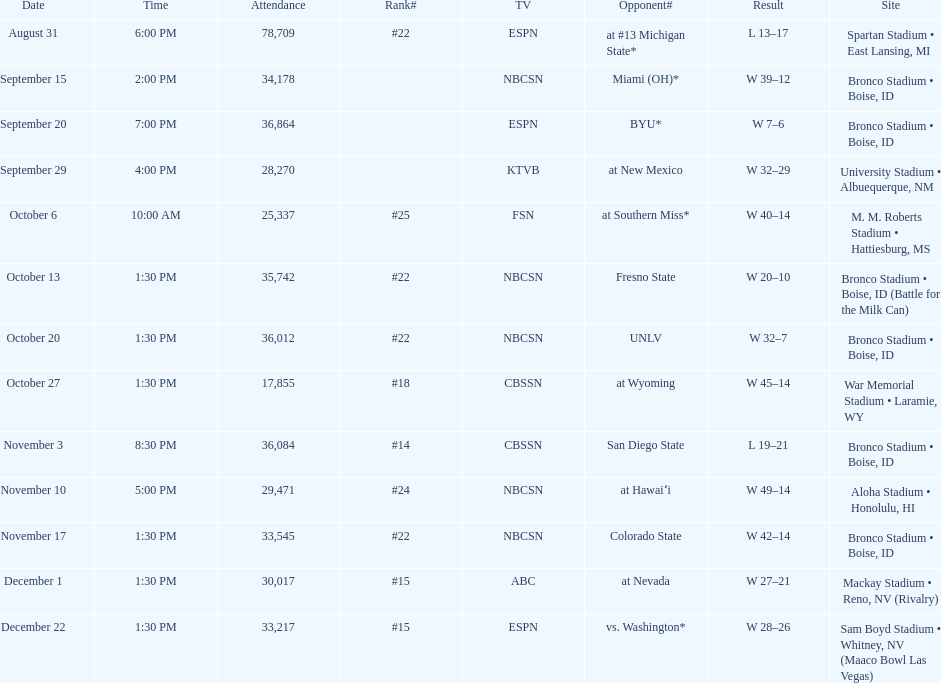What rank was boise state after november 10th? #22. 